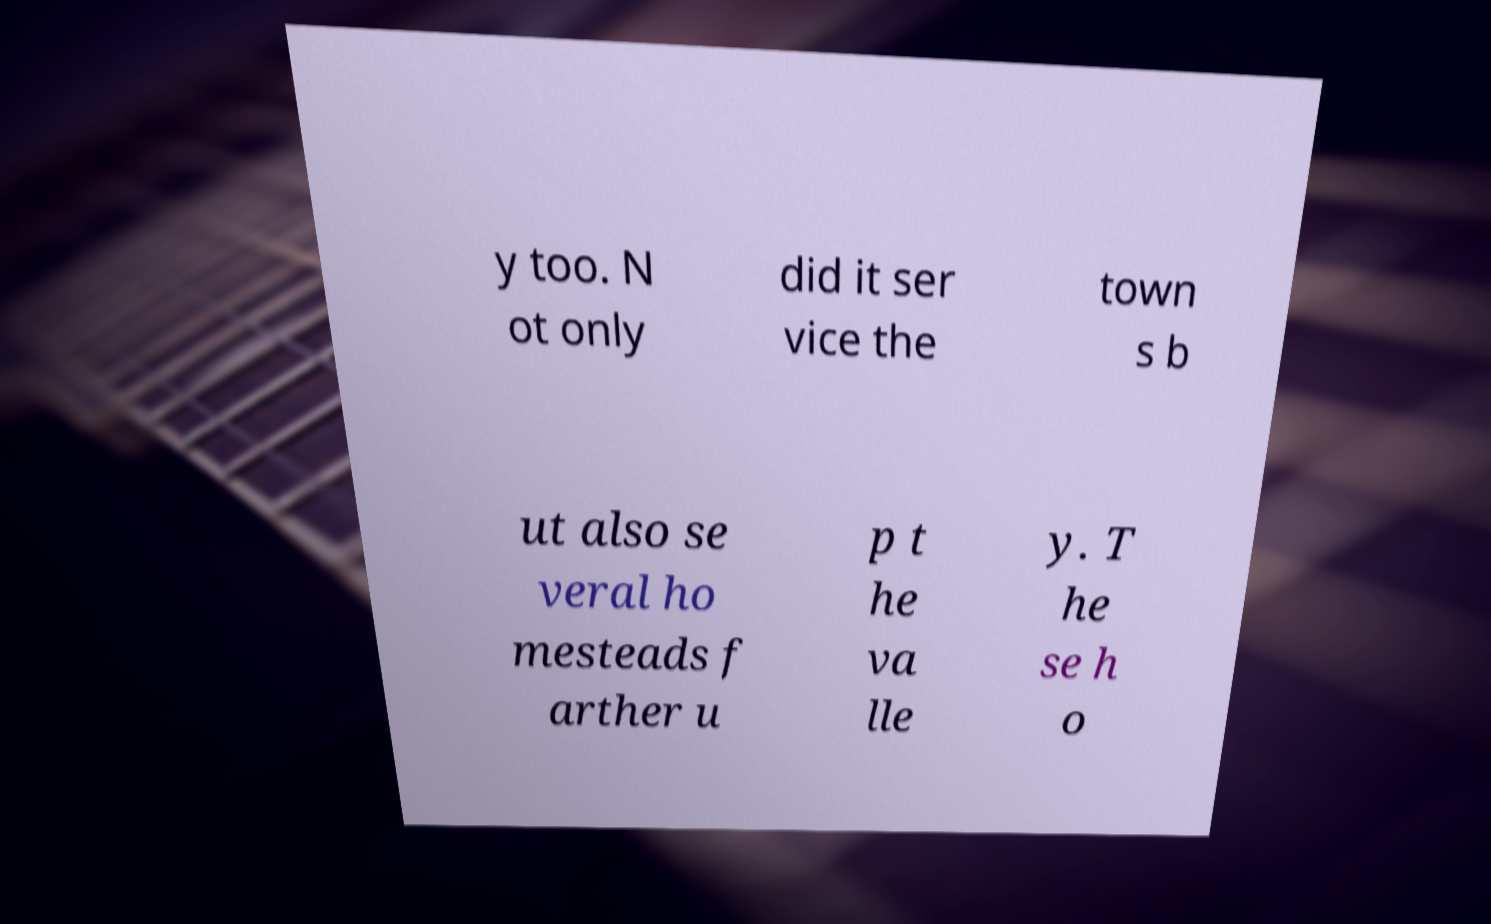I need the written content from this picture converted into text. Can you do that? y too. N ot only did it ser vice the town s b ut also se veral ho mesteads f arther u p t he va lle y. T he se h o 